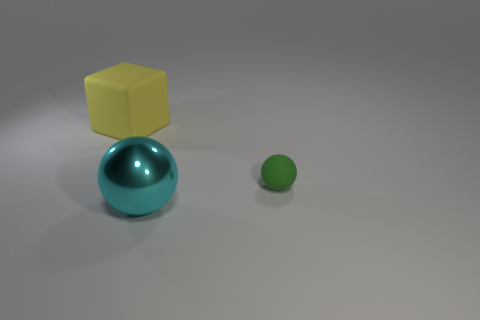Add 3 big gray balls. How many objects exist? 6 Subtract all green balls. How many balls are left? 1 Add 2 cyan objects. How many cyan objects are left? 3 Add 2 green things. How many green things exist? 3 Subtract 0 gray blocks. How many objects are left? 3 Subtract all cubes. How many objects are left? 2 Subtract 1 cubes. How many cubes are left? 0 Subtract all red cubes. Subtract all red cylinders. How many cubes are left? 1 Subtract all brown balls. How many green cubes are left? 0 Subtract all big cyan shiny objects. Subtract all cyan rubber spheres. How many objects are left? 2 